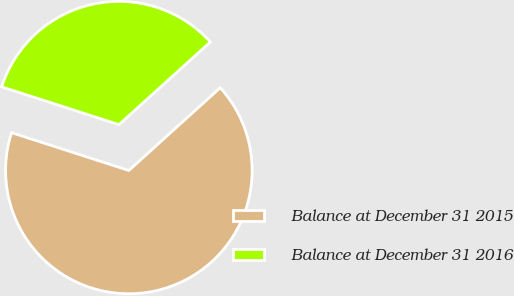Convert chart. <chart><loc_0><loc_0><loc_500><loc_500><pie_chart><fcel>Balance at December 31 2015<fcel>Balance at December 31 2016<nl><fcel>66.67%<fcel>33.33%<nl></chart> 